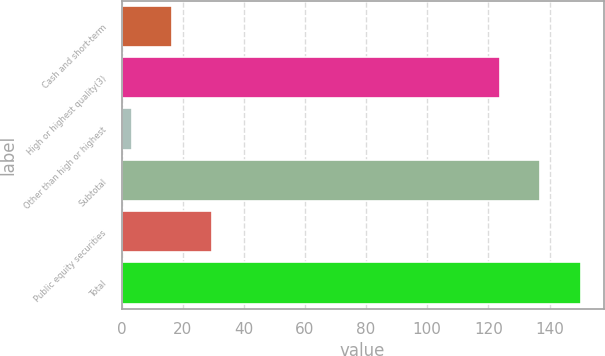<chart> <loc_0><loc_0><loc_500><loc_500><bar_chart><fcel>Cash and short-term<fcel>High or highest quality(3)<fcel>Other than high or highest<fcel>Subtotal<fcel>Public equity securities<fcel>Total<nl><fcel>16.49<fcel>123.8<fcel>3.3<fcel>136.99<fcel>29.68<fcel>150.18<nl></chart> 